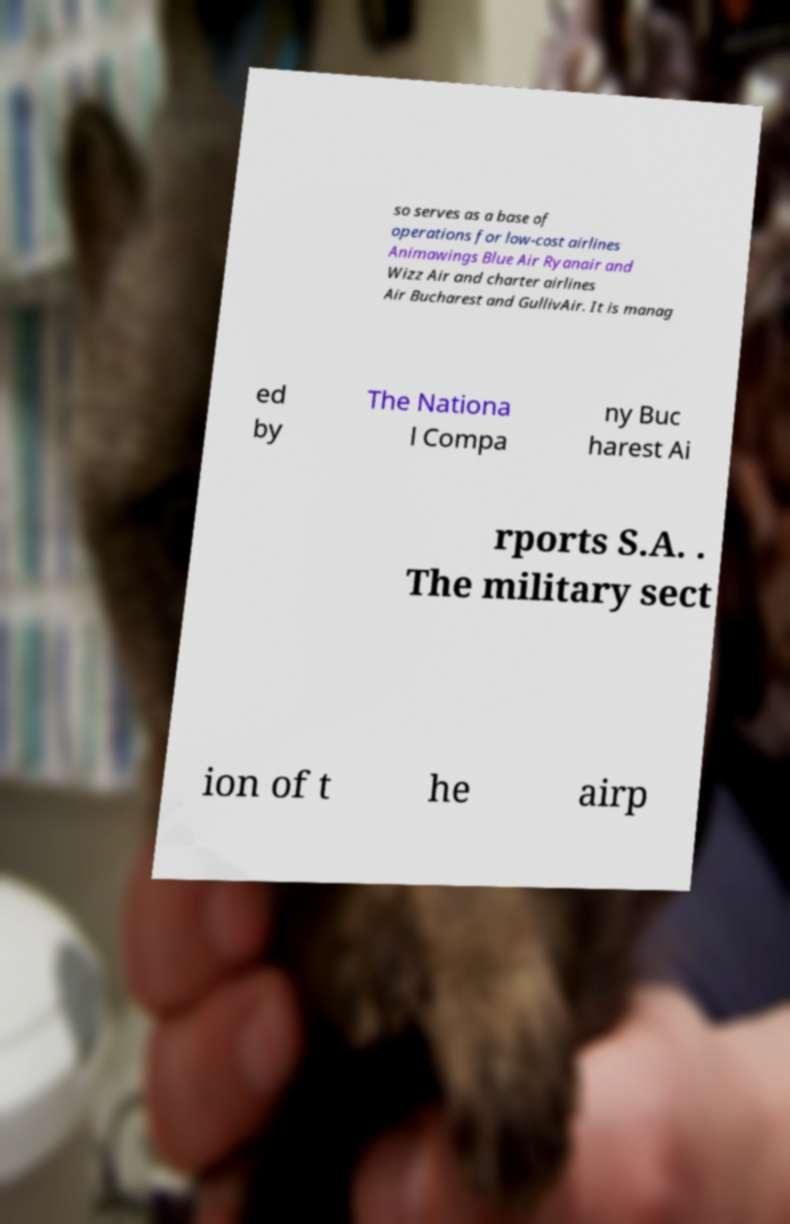Please identify and transcribe the text found in this image. so serves as a base of operations for low-cost airlines Animawings Blue Air Ryanair and Wizz Air and charter airlines Air Bucharest and GullivAir. It is manag ed by The Nationa l Compa ny Buc harest Ai rports S.A. . The military sect ion of t he airp 